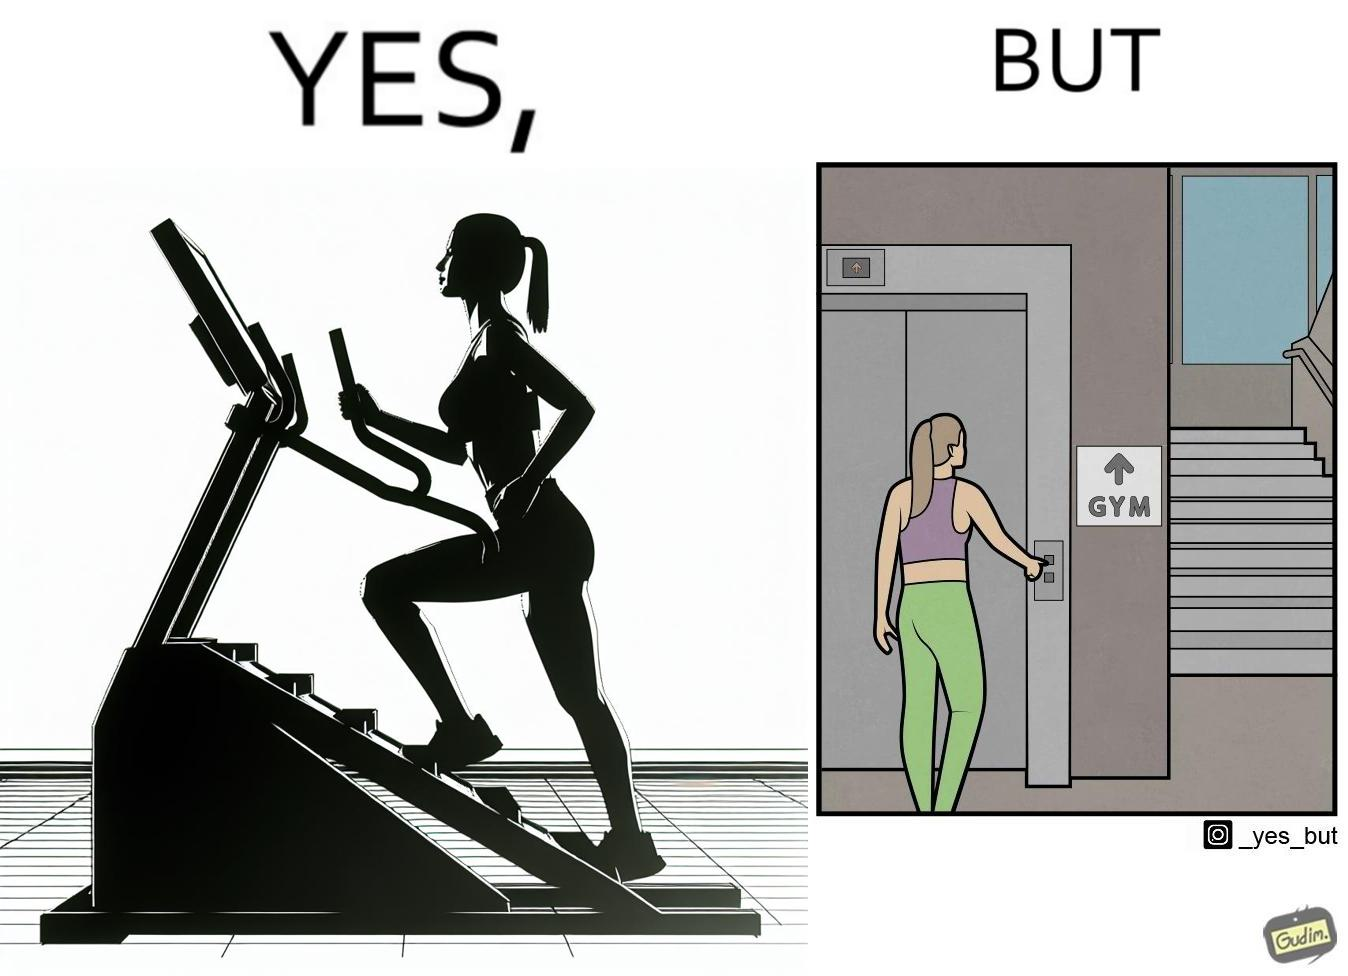Explain the humor or irony in this image. The image is ironic, because in the left image a woman is seen using the stair climber machine at the gym but the same woman is not ready to climb up some stairs for going to the gym and is calling for the lift 